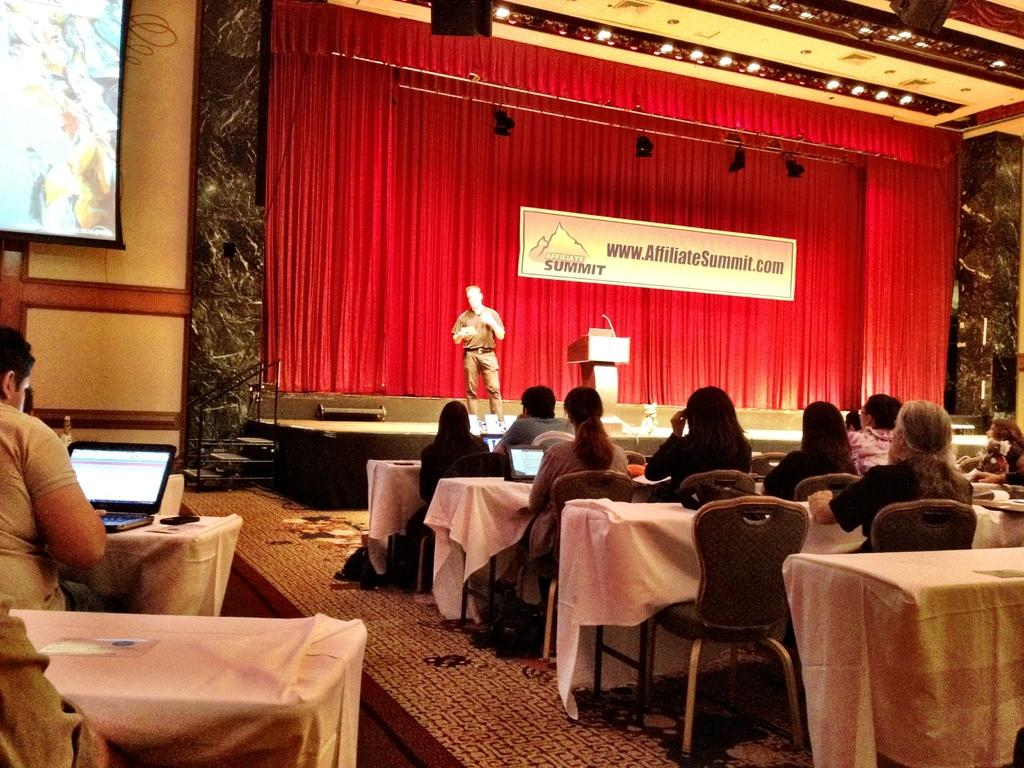What are the people in the image doing? There is a group of people sitting in chairs in the image. What is in front of the group of people? There is a table in front of the group of people. Is there anyone standing in the image? Yes, there is a person standing in front of the group of people. What color is the background curtain in the image? The background curtain is red in color. Can you tell me how many yaks are present in the image? There are no yaks present in the image. What type of leather is used for the chairs in the image? The image does not provide information about the material used for the chairs. 